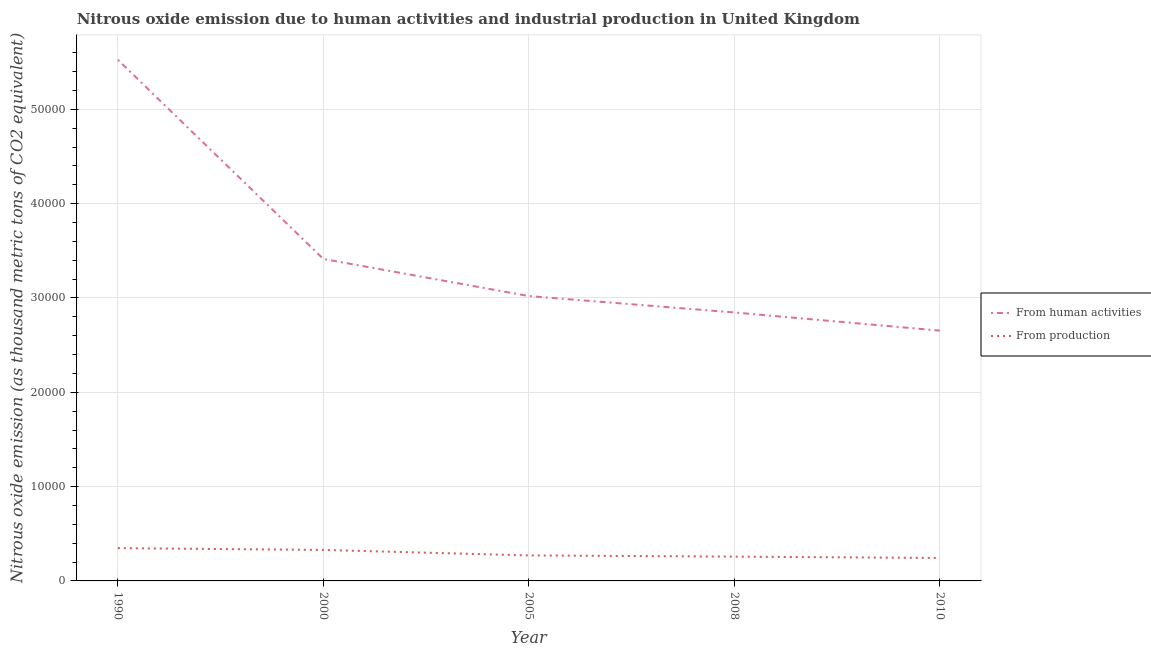Does the line corresponding to amount of emissions from human activities intersect with the line corresponding to amount of emissions generated from industries?
Your answer should be very brief. No. Is the number of lines equal to the number of legend labels?
Your response must be concise. Yes. What is the amount of emissions generated from industries in 2000?
Your answer should be very brief. 3284.4. Across all years, what is the maximum amount of emissions from human activities?
Offer a very short reply. 5.53e+04. Across all years, what is the minimum amount of emissions from human activities?
Ensure brevity in your answer.  2.65e+04. What is the total amount of emissions from human activities in the graph?
Provide a short and direct response. 1.75e+05. What is the difference between the amount of emissions generated from industries in 2000 and that in 2005?
Offer a very short reply. 580. What is the difference between the amount of emissions from human activities in 2010 and the amount of emissions generated from industries in 2000?
Offer a very short reply. 2.33e+04. What is the average amount of emissions from human activities per year?
Provide a succinct answer. 3.49e+04. In the year 2010, what is the difference between the amount of emissions generated from industries and amount of emissions from human activities?
Make the answer very short. -2.41e+04. What is the ratio of the amount of emissions from human activities in 2000 to that in 2005?
Provide a short and direct response. 1.13. Is the amount of emissions from human activities in 1990 less than that in 2000?
Offer a terse response. No. What is the difference between the highest and the second highest amount of emissions from human activities?
Provide a short and direct response. 2.11e+04. What is the difference between the highest and the lowest amount of emissions generated from industries?
Provide a succinct answer. 1043.5. In how many years, is the amount of emissions generated from industries greater than the average amount of emissions generated from industries taken over all years?
Your answer should be compact. 2. Is the sum of the amount of emissions from human activities in 1990 and 2010 greater than the maximum amount of emissions generated from industries across all years?
Your answer should be very brief. Yes. Does the amount of emissions generated from industries monotonically increase over the years?
Make the answer very short. No. Is the amount of emissions from human activities strictly greater than the amount of emissions generated from industries over the years?
Your answer should be compact. Yes. How many lines are there?
Provide a succinct answer. 2. How many years are there in the graph?
Ensure brevity in your answer.  5. What is the difference between two consecutive major ticks on the Y-axis?
Your answer should be compact. 10000. Are the values on the major ticks of Y-axis written in scientific E-notation?
Keep it short and to the point. No. Does the graph contain any zero values?
Your answer should be compact. No. Does the graph contain grids?
Your answer should be very brief. Yes. What is the title of the graph?
Ensure brevity in your answer.  Nitrous oxide emission due to human activities and industrial production in United Kingdom. Does "Commercial bank branches" appear as one of the legend labels in the graph?
Provide a succinct answer. No. What is the label or title of the Y-axis?
Ensure brevity in your answer.  Nitrous oxide emission (as thousand metric tons of CO2 equivalent). What is the Nitrous oxide emission (as thousand metric tons of CO2 equivalent) of From human activities in 1990?
Keep it short and to the point. 5.53e+04. What is the Nitrous oxide emission (as thousand metric tons of CO2 equivalent) of From production in 1990?
Provide a succinct answer. 3476.7. What is the Nitrous oxide emission (as thousand metric tons of CO2 equivalent) in From human activities in 2000?
Offer a terse response. 3.41e+04. What is the Nitrous oxide emission (as thousand metric tons of CO2 equivalent) of From production in 2000?
Give a very brief answer. 3284.4. What is the Nitrous oxide emission (as thousand metric tons of CO2 equivalent) in From human activities in 2005?
Give a very brief answer. 3.02e+04. What is the Nitrous oxide emission (as thousand metric tons of CO2 equivalent) of From production in 2005?
Keep it short and to the point. 2704.4. What is the Nitrous oxide emission (as thousand metric tons of CO2 equivalent) of From human activities in 2008?
Give a very brief answer. 2.85e+04. What is the Nitrous oxide emission (as thousand metric tons of CO2 equivalent) in From production in 2008?
Provide a succinct answer. 2576.5. What is the Nitrous oxide emission (as thousand metric tons of CO2 equivalent) of From human activities in 2010?
Offer a terse response. 2.65e+04. What is the Nitrous oxide emission (as thousand metric tons of CO2 equivalent) in From production in 2010?
Make the answer very short. 2433.2. Across all years, what is the maximum Nitrous oxide emission (as thousand metric tons of CO2 equivalent) in From human activities?
Offer a very short reply. 5.53e+04. Across all years, what is the maximum Nitrous oxide emission (as thousand metric tons of CO2 equivalent) in From production?
Make the answer very short. 3476.7. Across all years, what is the minimum Nitrous oxide emission (as thousand metric tons of CO2 equivalent) in From human activities?
Offer a very short reply. 2.65e+04. Across all years, what is the minimum Nitrous oxide emission (as thousand metric tons of CO2 equivalent) in From production?
Ensure brevity in your answer.  2433.2. What is the total Nitrous oxide emission (as thousand metric tons of CO2 equivalent) in From human activities in the graph?
Offer a terse response. 1.75e+05. What is the total Nitrous oxide emission (as thousand metric tons of CO2 equivalent) of From production in the graph?
Offer a terse response. 1.45e+04. What is the difference between the Nitrous oxide emission (as thousand metric tons of CO2 equivalent) in From human activities in 1990 and that in 2000?
Your answer should be compact. 2.11e+04. What is the difference between the Nitrous oxide emission (as thousand metric tons of CO2 equivalent) in From production in 1990 and that in 2000?
Provide a short and direct response. 192.3. What is the difference between the Nitrous oxide emission (as thousand metric tons of CO2 equivalent) in From human activities in 1990 and that in 2005?
Ensure brevity in your answer.  2.51e+04. What is the difference between the Nitrous oxide emission (as thousand metric tons of CO2 equivalent) of From production in 1990 and that in 2005?
Ensure brevity in your answer.  772.3. What is the difference between the Nitrous oxide emission (as thousand metric tons of CO2 equivalent) in From human activities in 1990 and that in 2008?
Give a very brief answer. 2.68e+04. What is the difference between the Nitrous oxide emission (as thousand metric tons of CO2 equivalent) in From production in 1990 and that in 2008?
Provide a short and direct response. 900.2. What is the difference between the Nitrous oxide emission (as thousand metric tons of CO2 equivalent) in From human activities in 1990 and that in 2010?
Your answer should be compact. 2.87e+04. What is the difference between the Nitrous oxide emission (as thousand metric tons of CO2 equivalent) of From production in 1990 and that in 2010?
Ensure brevity in your answer.  1043.5. What is the difference between the Nitrous oxide emission (as thousand metric tons of CO2 equivalent) of From human activities in 2000 and that in 2005?
Offer a terse response. 3932.5. What is the difference between the Nitrous oxide emission (as thousand metric tons of CO2 equivalent) in From production in 2000 and that in 2005?
Offer a very short reply. 580. What is the difference between the Nitrous oxide emission (as thousand metric tons of CO2 equivalent) in From human activities in 2000 and that in 2008?
Your response must be concise. 5669.2. What is the difference between the Nitrous oxide emission (as thousand metric tons of CO2 equivalent) of From production in 2000 and that in 2008?
Provide a succinct answer. 707.9. What is the difference between the Nitrous oxide emission (as thousand metric tons of CO2 equivalent) in From human activities in 2000 and that in 2010?
Provide a short and direct response. 7595.2. What is the difference between the Nitrous oxide emission (as thousand metric tons of CO2 equivalent) in From production in 2000 and that in 2010?
Your answer should be compact. 851.2. What is the difference between the Nitrous oxide emission (as thousand metric tons of CO2 equivalent) of From human activities in 2005 and that in 2008?
Make the answer very short. 1736.7. What is the difference between the Nitrous oxide emission (as thousand metric tons of CO2 equivalent) in From production in 2005 and that in 2008?
Give a very brief answer. 127.9. What is the difference between the Nitrous oxide emission (as thousand metric tons of CO2 equivalent) of From human activities in 2005 and that in 2010?
Keep it short and to the point. 3662.7. What is the difference between the Nitrous oxide emission (as thousand metric tons of CO2 equivalent) of From production in 2005 and that in 2010?
Offer a very short reply. 271.2. What is the difference between the Nitrous oxide emission (as thousand metric tons of CO2 equivalent) of From human activities in 2008 and that in 2010?
Your answer should be very brief. 1926. What is the difference between the Nitrous oxide emission (as thousand metric tons of CO2 equivalent) of From production in 2008 and that in 2010?
Provide a succinct answer. 143.3. What is the difference between the Nitrous oxide emission (as thousand metric tons of CO2 equivalent) of From human activities in 1990 and the Nitrous oxide emission (as thousand metric tons of CO2 equivalent) of From production in 2000?
Your response must be concise. 5.20e+04. What is the difference between the Nitrous oxide emission (as thousand metric tons of CO2 equivalent) of From human activities in 1990 and the Nitrous oxide emission (as thousand metric tons of CO2 equivalent) of From production in 2005?
Keep it short and to the point. 5.25e+04. What is the difference between the Nitrous oxide emission (as thousand metric tons of CO2 equivalent) in From human activities in 1990 and the Nitrous oxide emission (as thousand metric tons of CO2 equivalent) in From production in 2008?
Ensure brevity in your answer.  5.27e+04. What is the difference between the Nitrous oxide emission (as thousand metric tons of CO2 equivalent) of From human activities in 1990 and the Nitrous oxide emission (as thousand metric tons of CO2 equivalent) of From production in 2010?
Make the answer very short. 5.28e+04. What is the difference between the Nitrous oxide emission (as thousand metric tons of CO2 equivalent) of From human activities in 2000 and the Nitrous oxide emission (as thousand metric tons of CO2 equivalent) of From production in 2005?
Your answer should be very brief. 3.14e+04. What is the difference between the Nitrous oxide emission (as thousand metric tons of CO2 equivalent) in From human activities in 2000 and the Nitrous oxide emission (as thousand metric tons of CO2 equivalent) in From production in 2008?
Your answer should be very brief. 3.16e+04. What is the difference between the Nitrous oxide emission (as thousand metric tons of CO2 equivalent) of From human activities in 2000 and the Nitrous oxide emission (as thousand metric tons of CO2 equivalent) of From production in 2010?
Your answer should be compact. 3.17e+04. What is the difference between the Nitrous oxide emission (as thousand metric tons of CO2 equivalent) in From human activities in 2005 and the Nitrous oxide emission (as thousand metric tons of CO2 equivalent) in From production in 2008?
Provide a short and direct response. 2.76e+04. What is the difference between the Nitrous oxide emission (as thousand metric tons of CO2 equivalent) in From human activities in 2005 and the Nitrous oxide emission (as thousand metric tons of CO2 equivalent) in From production in 2010?
Ensure brevity in your answer.  2.78e+04. What is the difference between the Nitrous oxide emission (as thousand metric tons of CO2 equivalent) of From human activities in 2008 and the Nitrous oxide emission (as thousand metric tons of CO2 equivalent) of From production in 2010?
Your answer should be very brief. 2.60e+04. What is the average Nitrous oxide emission (as thousand metric tons of CO2 equivalent) of From human activities per year?
Give a very brief answer. 3.49e+04. What is the average Nitrous oxide emission (as thousand metric tons of CO2 equivalent) of From production per year?
Your answer should be very brief. 2895.04. In the year 1990, what is the difference between the Nitrous oxide emission (as thousand metric tons of CO2 equivalent) in From human activities and Nitrous oxide emission (as thousand metric tons of CO2 equivalent) in From production?
Keep it short and to the point. 5.18e+04. In the year 2000, what is the difference between the Nitrous oxide emission (as thousand metric tons of CO2 equivalent) of From human activities and Nitrous oxide emission (as thousand metric tons of CO2 equivalent) of From production?
Your response must be concise. 3.08e+04. In the year 2005, what is the difference between the Nitrous oxide emission (as thousand metric tons of CO2 equivalent) of From human activities and Nitrous oxide emission (as thousand metric tons of CO2 equivalent) of From production?
Make the answer very short. 2.75e+04. In the year 2008, what is the difference between the Nitrous oxide emission (as thousand metric tons of CO2 equivalent) in From human activities and Nitrous oxide emission (as thousand metric tons of CO2 equivalent) in From production?
Ensure brevity in your answer.  2.59e+04. In the year 2010, what is the difference between the Nitrous oxide emission (as thousand metric tons of CO2 equivalent) in From human activities and Nitrous oxide emission (as thousand metric tons of CO2 equivalent) in From production?
Your answer should be very brief. 2.41e+04. What is the ratio of the Nitrous oxide emission (as thousand metric tons of CO2 equivalent) of From human activities in 1990 to that in 2000?
Offer a terse response. 1.62. What is the ratio of the Nitrous oxide emission (as thousand metric tons of CO2 equivalent) of From production in 1990 to that in 2000?
Keep it short and to the point. 1.06. What is the ratio of the Nitrous oxide emission (as thousand metric tons of CO2 equivalent) of From human activities in 1990 to that in 2005?
Ensure brevity in your answer.  1.83. What is the ratio of the Nitrous oxide emission (as thousand metric tons of CO2 equivalent) in From production in 1990 to that in 2005?
Provide a short and direct response. 1.29. What is the ratio of the Nitrous oxide emission (as thousand metric tons of CO2 equivalent) in From human activities in 1990 to that in 2008?
Your response must be concise. 1.94. What is the ratio of the Nitrous oxide emission (as thousand metric tons of CO2 equivalent) in From production in 1990 to that in 2008?
Make the answer very short. 1.35. What is the ratio of the Nitrous oxide emission (as thousand metric tons of CO2 equivalent) of From human activities in 1990 to that in 2010?
Keep it short and to the point. 2.08. What is the ratio of the Nitrous oxide emission (as thousand metric tons of CO2 equivalent) of From production in 1990 to that in 2010?
Ensure brevity in your answer.  1.43. What is the ratio of the Nitrous oxide emission (as thousand metric tons of CO2 equivalent) of From human activities in 2000 to that in 2005?
Your answer should be compact. 1.13. What is the ratio of the Nitrous oxide emission (as thousand metric tons of CO2 equivalent) of From production in 2000 to that in 2005?
Offer a terse response. 1.21. What is the ratio of the Nitrous oxide emission (as thousand metric tons of CO2 equivalent) in From human activities in 2000 to that in 2008?
Provide a short and direct response. 1.2. What is the ratio of the Nitrous oxide emission (as thousand metric tons of CO2 equivalent) in From production in 2000 to that in 2008?
Offer a terse response. 1.27. What is the ratio of the Nitrous oxide emission (as thousand metric tons of CO2 equivalent) of From human activities in 2000 to that in 2010?
Make the answer very short. 1.29. What is the ratio of the Nitrous oxide emission (as thousand metric tons of CO2 equivalent) of From production in 2000 to that in 2010?
Offer a very short reply. 1.35. What is the ratio of the Nitrous oxide emission (as thousand metric tons of CO2 equivalent) of From human activities in 2005 to that in 2008?
Provide a short and direct response. 1.06. What is the ratio of the Nitrous oxide emission (as thousand metric tons of CO2 equivalent) of From production in 2005 to that in 2008?
Your response must be concise. 1.05. What is the ratio of the Nitrous oxide emission (as thousand metric tons of CO2 equivalent) in From human activities in 2005 to that in 2010?
Provide a succinct answer. 1.14. What is the ratio of the Nitrous oxide emission (as thousand metric tons of CO2 equivalent) in From production in 2005 to that in 2010?
Keep it short and to the point. 1.11. What is the ratio of the Nitrous oxide emission (as thousand metric tons of CO2 equivalent) in From human activities in 2008 to that in 2010?
Your answer should be very brief. 1.07. What is the ratio of the Nitrous oxide emission (as thousand metric tons of CO2 equivalent) in From production in 2008 to that in 2010?
Provide a short and direct response. 1.06. What is the difference between the highest and the second highest Nitrous oxide emission (as thousand metric tons of CO2 equivalent) in From human activities?
Give a very brief answer. 2.11e+04. What is the difference between the highest and the second highest Nitrous oxide emission (as thousand metric tons of CO2 equivalent) of From production?
Provide a short and direct response. 192.3. What is the difference between the highest and the lowest Nitrous oxide emission (as thousand metric tons of CO2 equivalent) of From human activities?
Ensure brevity in your answer.  2.87e+04. What is the difference between the highest and the lowest Nitrous oxide emission (as thousand metric tons of CO2 equivalent) in From production?
Keep it short and to the point. 1043.5. 